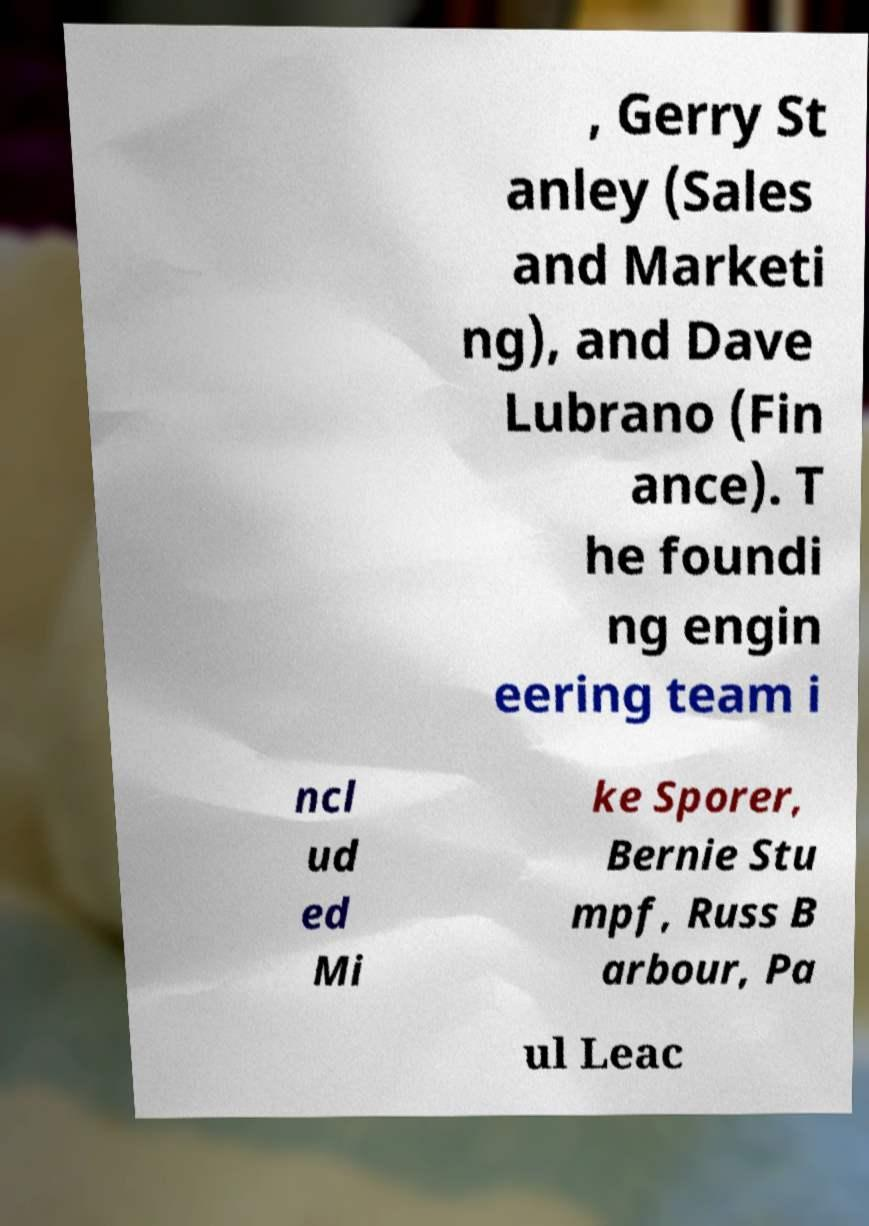For documentation purposes, I need the text within this image transcribed. Could you provide that? , Gerry St anley (Sales and Marketi ng), and Dave Lubrano (Fin ance). T he foundi ng engin eering team i ncl ud ed Mi ke Sporer, Bernie Stu mpf, Russ B arbour, Pa ul Leac 